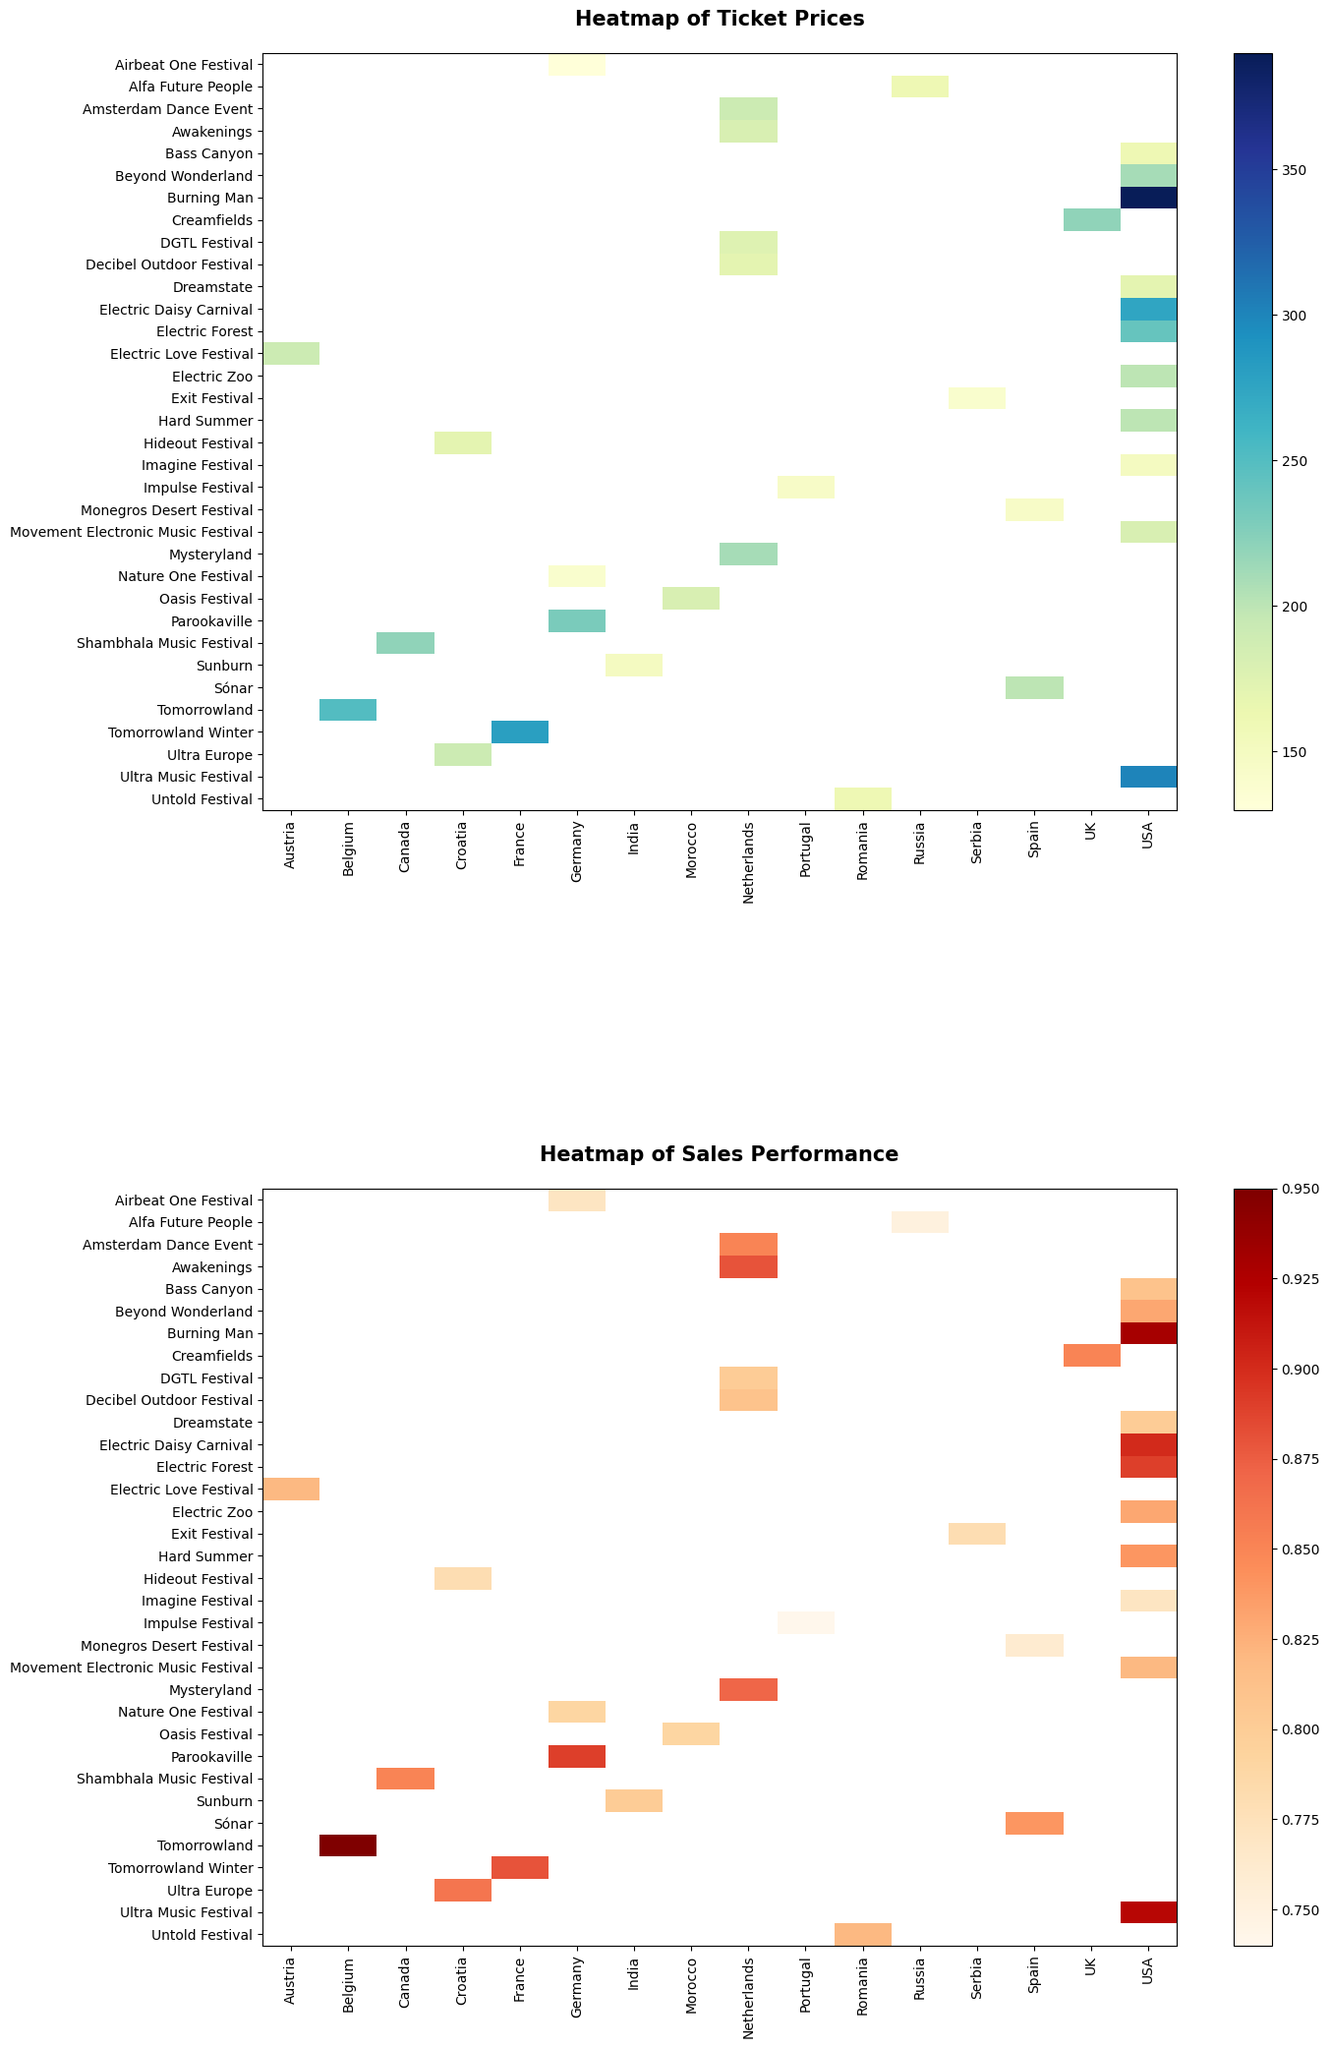What is the festival with the highest ticket price? Start by examining the top heatmap for the darkest blue cell indicating the highest value. Note the corresponding festival name.
Answer: Burning Man What is the range of ticket prices for festivals in the USA? Identify the ticket prices for USA festivals from the top heatmap, which are Electric Daisy Carnival, Ultra Music Festival, and others. Find the maximum and minimum values. Maximum = 300, Minimum = 150, thus the range is 300 - 150.
Answer: 150 Which festival in Germany has the highest sales performance? Locate the festivals in Germany on the bottom heatmap, and find the cell with the darkest shade of red. Note the corresponding festival name.
Answer: Parookaville How does Tomorrowland's ticket price compare to Sunburn's? On the top heatmap, identify the ticket price entries for Tomorrowland and Sunburn. Compare the two values.
Answer: Tomorrowland's ticket price is higher Which country has the most consistent sales performance across its festivals? Examine the bottom heatmap, and look for a country whose festivals have similar shades of red (indicating consistent values). Note the uniformity in shades.
Answer: Netherlands What is the average ticket price for festivals in Belgium and the USA? Identify ticket prices for Belgium (Tomorrowland) and the USA (e.g., Ultra Music Festival, Electric Daisy Carnival). Sum the values and divide by the number of festivals: (250 + 300 + 275 + 240 + 200 + 390)/6. Average = 2758/6.
Answer: Approximately 459.67 Which festival in the Netherlands has the lowest sales performance? Look at the bottom heatmap for the Netherlands festivals and identify the cell with the lightest shade of red. Note the corresponding festival name.
Answer: DGTL Festival How does the ticket price variation in Germany compare to that in the Netherlands? Compare the range of ticket prices in Germany (maximum - minimum = 230-130=100) to the range in the Netherlands (maximum - minimum = 210-170=40).
Answer: Germany has a wider variation What is the correlation between ticket price and sales performance for festivals in the USA? Since this is a visual comparison, observe the top and bottom heatmaps for the USA. Note if higher ticket prices generally correspond to higher sales performance.
Answer: Positive correlation Which specific festival had a ticket price of 250 and a sales performance of 0.95? Examine the heatmaps and match the visual attributes with the specific values given in the question.
Answer: Tomorrowland 